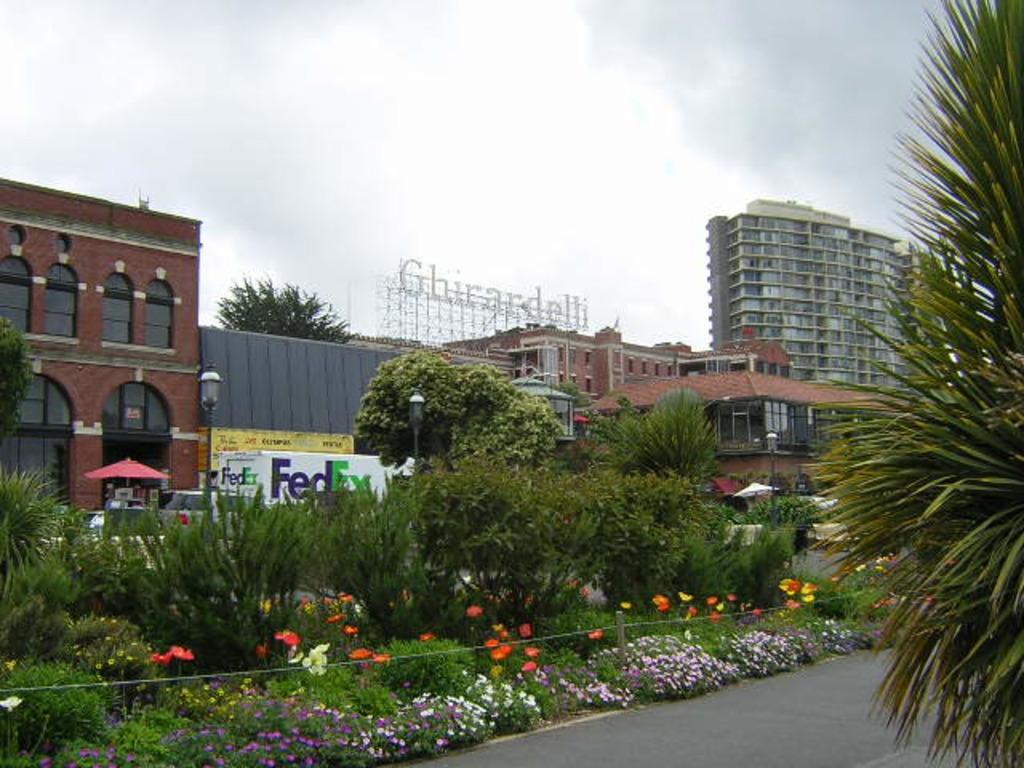Describe this image in one or two sentences. In this picture there are buildings and trees and street lights and there are vehicles on the road and there is an umbrella and there is a text on the building. At the top there is sky and there are clouds. At the bottom there is a road and there are plants and flowers. 